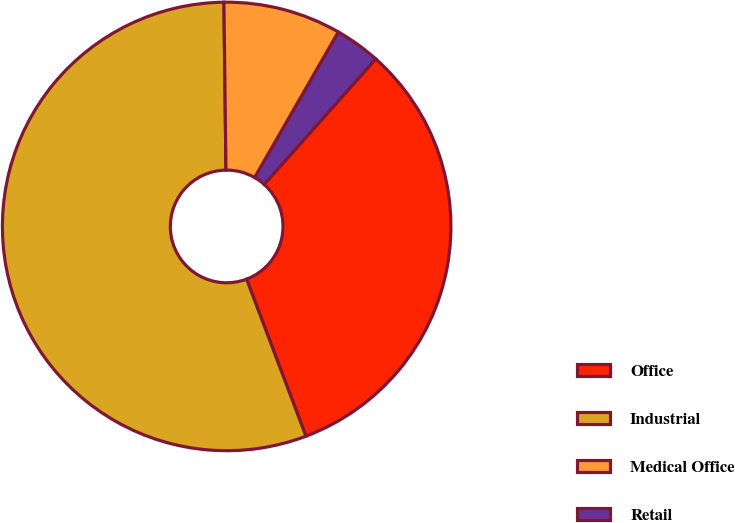<chart> <loc_0><loc_0><loc_500><loc_500><pie_chart><fcel>Office<fcel>Industrial<fcel>Medical Office<fcel>Retail<nl><fcel>32.68%<fcel>55.56%<fcel>8.5%<fcel>3.27%<nl></chart> 